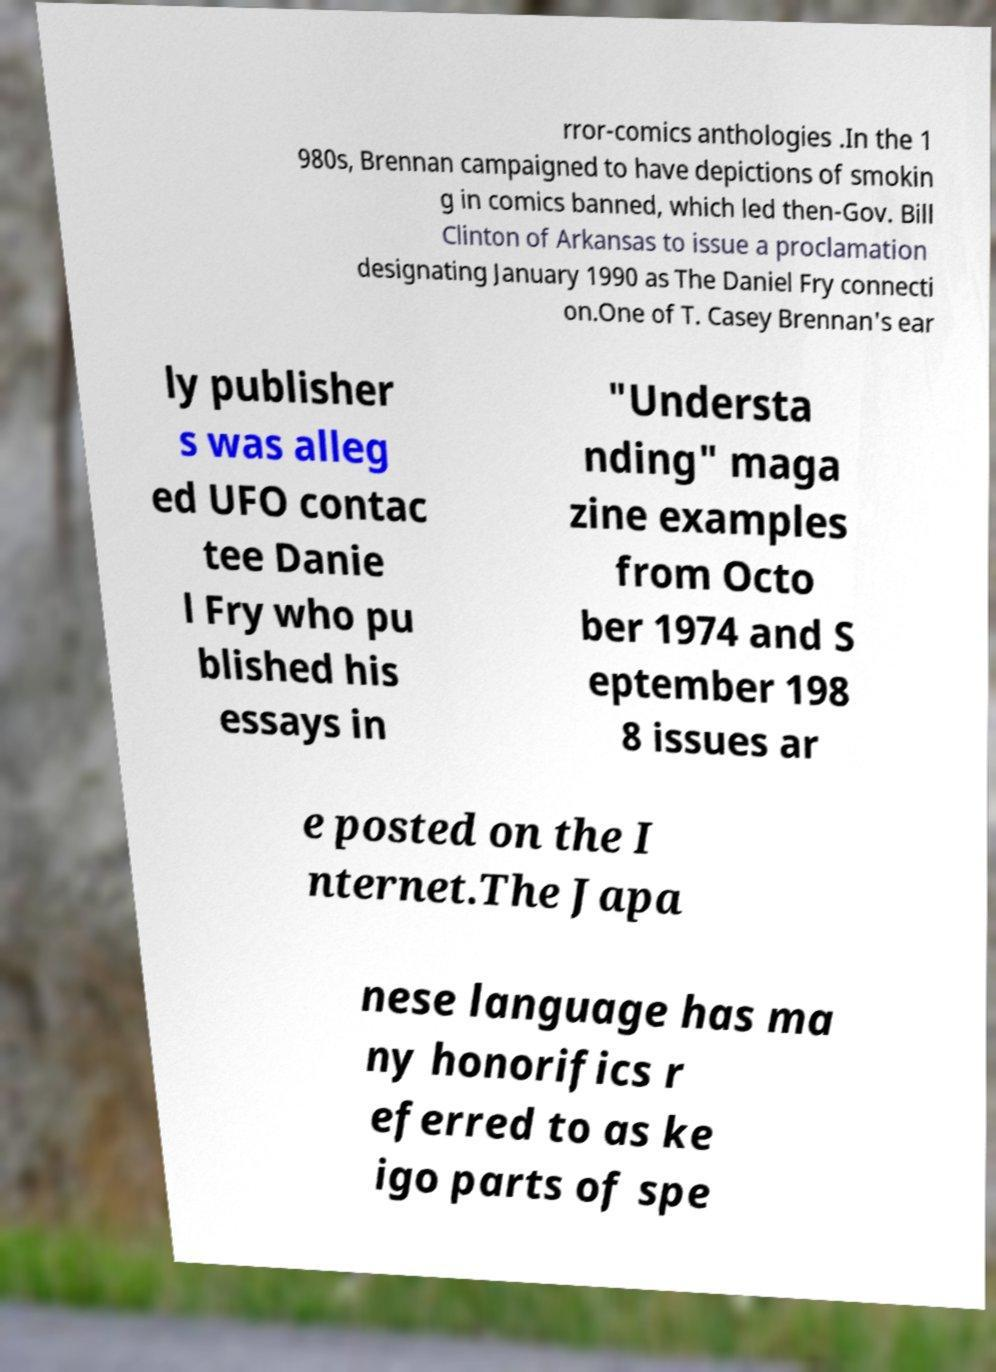Could you extract and type out the text from this image? rror-comics anthologies .In the 1 980s, Brennan campaigned to have depictions of smokin g in comics banned, which led then-Gov. Bill Clinton of Arkansas to issue a proclamation designating January 1990 as The Daniel Fry connecti on.One of T. Casey Brennan's ear ly publisher s was alleg ed UFO contac tee Danie l Fry who pu blished his essays in "Understa nding" maga zine examples from Octo ber 1974 and S eptember 198 8 issues ar e posted on the I nternet.The Japa nese language has ma ny honorifics r eferred to as ke igo parts of spe 